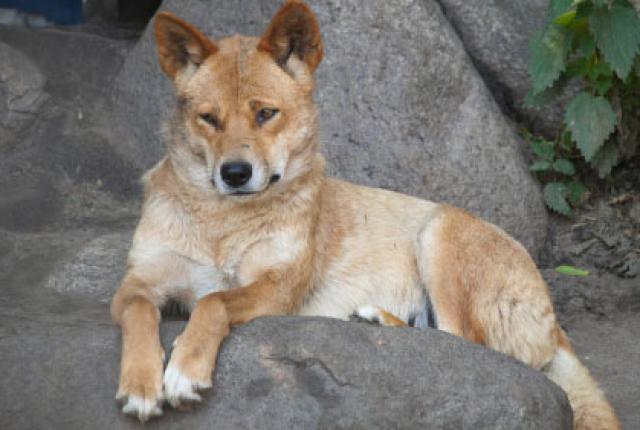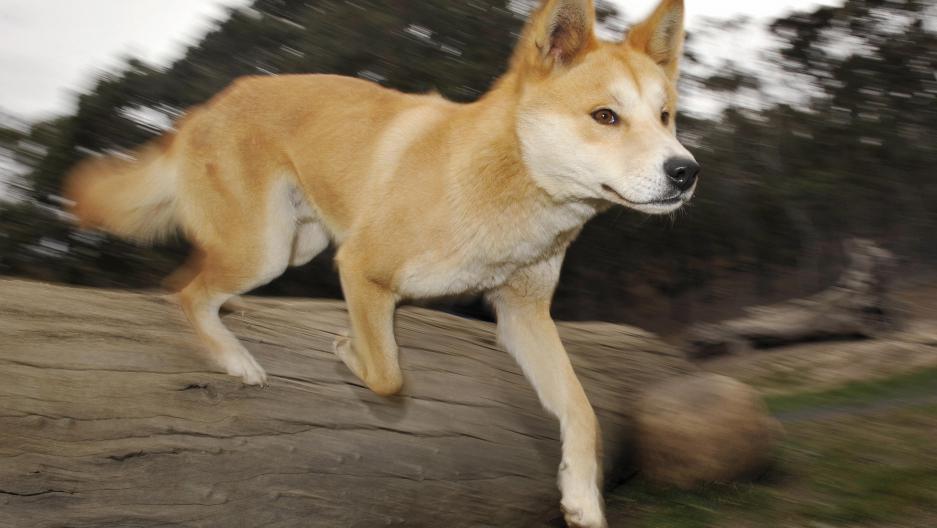The first image is the image on the left, the second image is the image on the right. Given the left and right images, does the statement "The dog on the right image is running." hold true? Answer yes or no. Yes. 